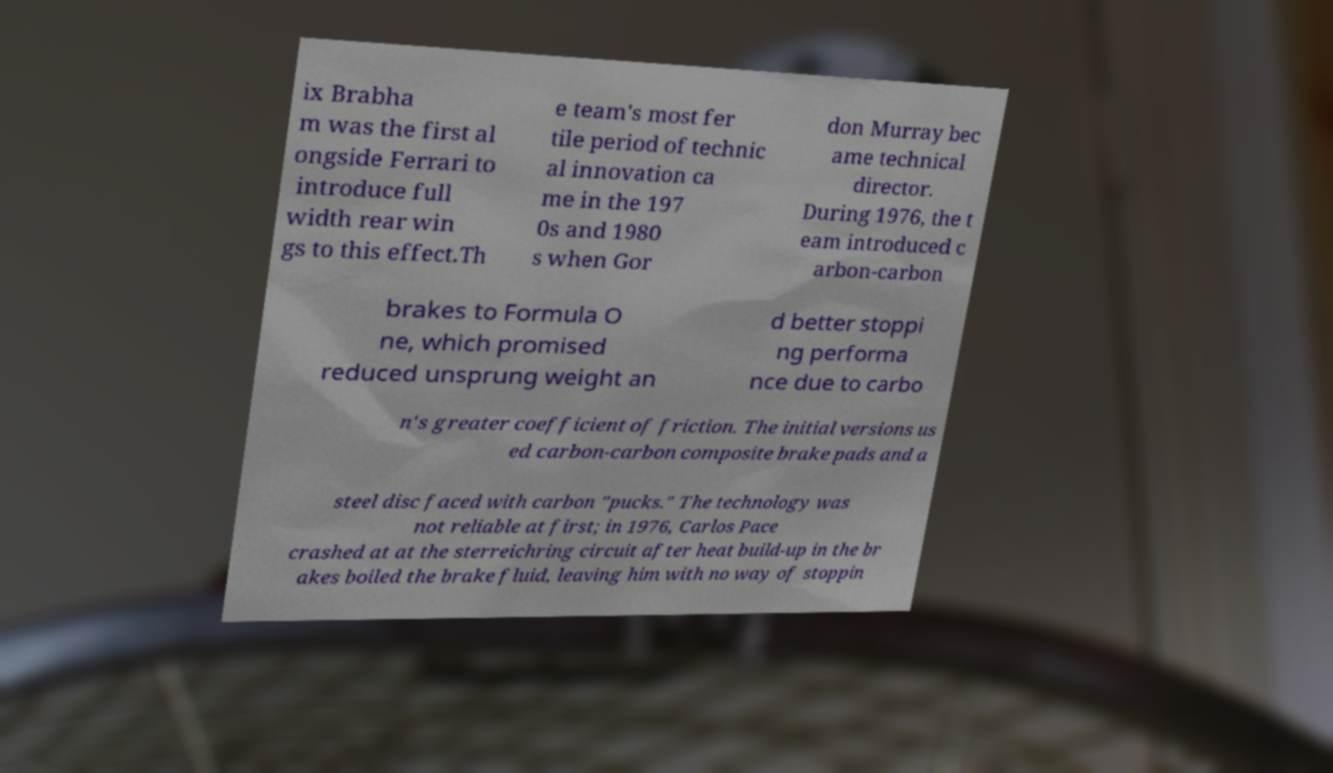Could you assist in decoding the text presented in this image and type it out clearly? ix Brabha m was the first al ongside Ferrari to introduce full width rear win gs to this effect.Th e team's most fer tile period of technic al innovation ca me in the 197 0s and 1980 s when Gor don Murray bec ame technical director. During 1976, the t eam introduced c arbon-carbon brakes to Formula O ne, which promised reduced unsprung weight an d better stoppi ng performa nce due to carbo n's greater coefficient of friction. The initial versions us ed carbon-carbon composite brake pads and a steel disc faced with carbon "pucks." The technology was not reliable at first; in 1976, Carlos Pace crashed at at the sterreichring circuit after heat build-up in the br akes boiled the brake fluid, leaving him with no way of stoppin 